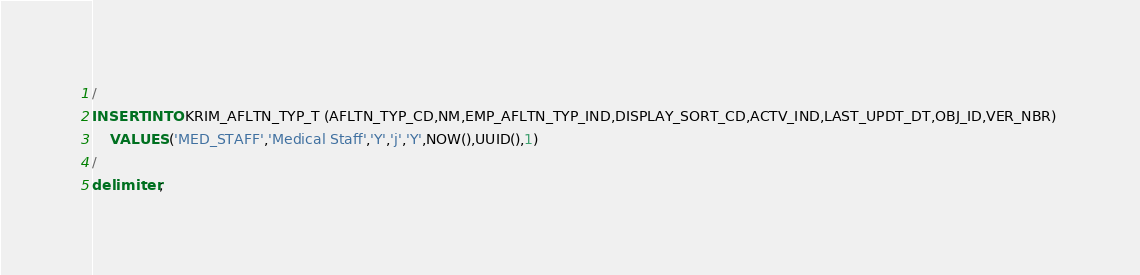Convert code to text. <code><loc_0><loc_0><loc_500><loc_500><_SQL_>/
INSERT INTO KRIM_AFLTN_TYP_T (AFLTN_TYP_CD,NM,EMP_AFLTN_TYP_IND,DISPLAY_SORT_CD,ACTV_IND,LAST_UPDT_DT,OBJ_ID,VER_NBR) 
    VALUES ('MED_STAFF','Medical Staff','Y','j','Y',NOW(),UUID(),1)
/
delimiter ;
</code> 